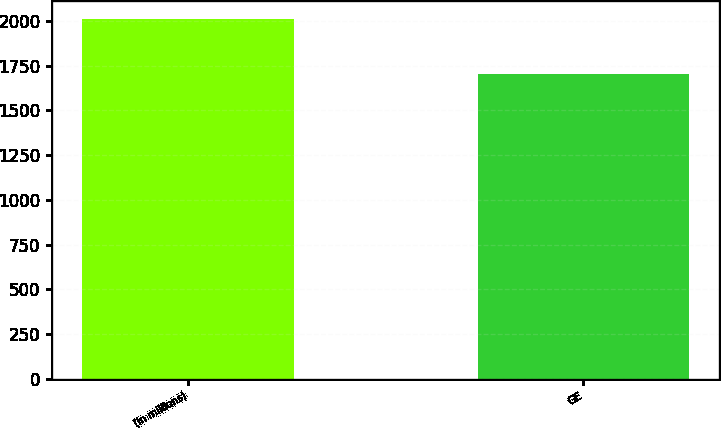Convert chart. <chart><loc_0><loc_0><loc_500><loc_500><bar_chart><fcel>(In millions)<fcel>GE<nl><fcel>2009<fcel>1703<nl></chart> 